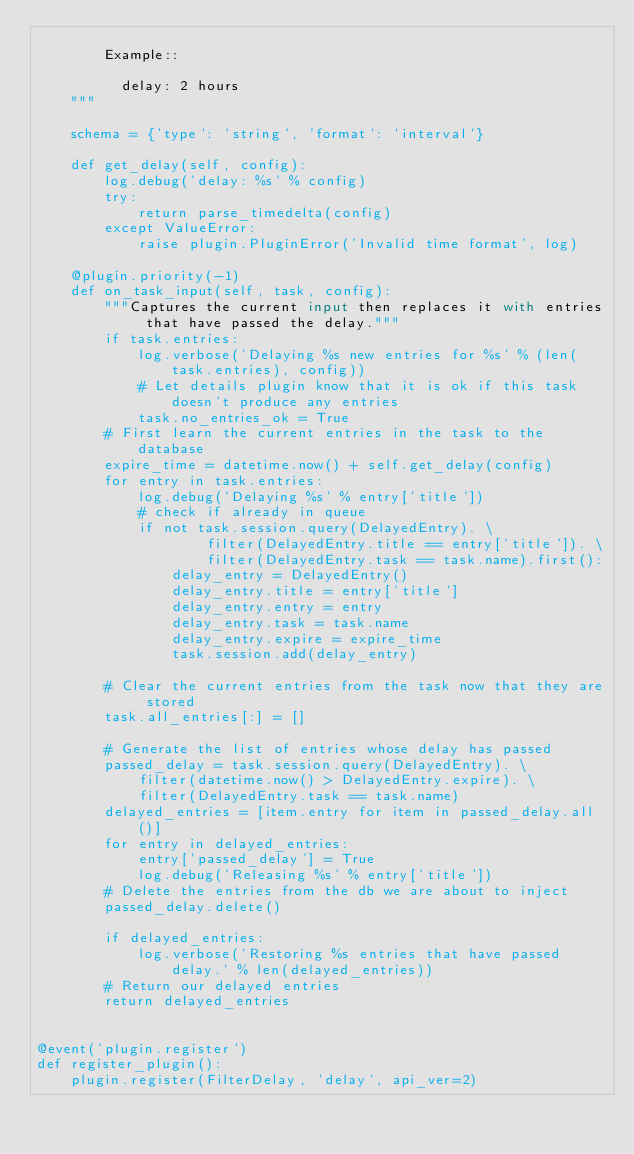<code> <loc_0><loc_0><loc_500><loc_500><_Python_>
        Example::

          delay: 2 hours
    """

    schema = {'type': 'string', 'format': 'interval'}

    def get_delay(self, config):
        log.debug('delay: %s' % config)
        try:
            return parse_timedelta(config)
        except ValueError:
            raise plugin.PluginError('Invalid time format', log)

    @plugin.priority(-1)
    def on_task_input(self, task, config):
        """Captures the current input then replaces it with entries that have passed the delay."""
        if task.entries:
            log.verbose('Delaying %s new entries for %s' % (len(task.entries), config))
            # Let details plugin know that it is ok if this task doesn't produce any entries
            task.no_entries_ok = True
        # First learn the current entries in the task to the database
        expire_time = datetime.now() + self.get_delay(config)
        for entry in task.entries:
            log.debug('Delaying %s' % entry['title'])
            # check if already in queue
            if not task.session.query(DelayedEntry). \
                    filter(DelayedEntry.title == entry['title']). \
                    filter(DelayedEntry.task == task.name).first():
                delay_entry = DelayedEntry()
                delay_entry.title = entry['title']
                delay_entry.entry = entry
                delay_entry.task = task.name
                delay_entry.expire = expire_time
                task.session.add(delay_entry)

        # Clear the current entries from the task now that they are stored
        task.all_entries[:] = []

        # Generate the list of entries whose delay has passed
        passed_delay = task.session.query(DelayedEntry). \
            filter(datetime.now() > DelayedEntry.expire). \
            filter(DelayedEntry.task == task.name)
        delayed_entries = [item.entry for item in passed_delay.all()]
        for entry in delayed_entries:
            entry['passed_delay'] = True
            log.debug('Releasing %s' % entry['title'])
        # Delete the entries from the db we are about to inject
        passed_delay.delete()

        if delayed_entries:
            log.verbose('Restoring %s entries that have passed delay.' % len(delayed_entries))
        # Return our delayed entries
        return delayed_entries


@event('plugin.register')
def register_plugin():
    plugin.register(FilterDelay, 'delay', api_ver=2)
</code> 